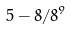<formula> <loc_0><loc_0><loc_500><loc_500>5 - 8 / 8 ^ { 9 }</formula> 